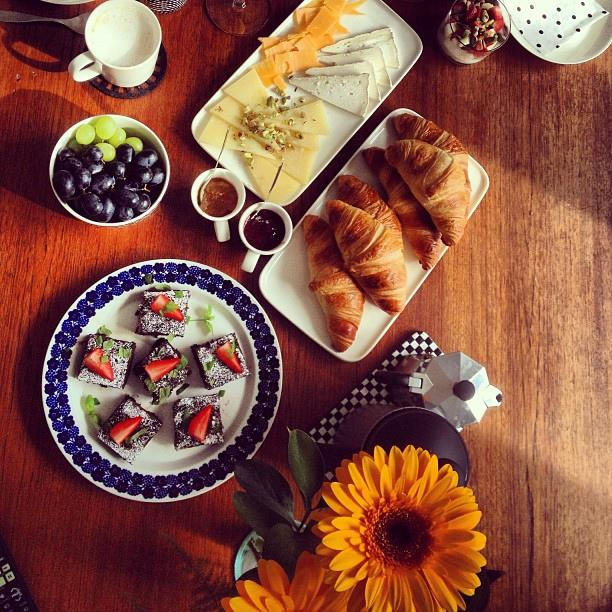Which people group invented the bread seen here? french 